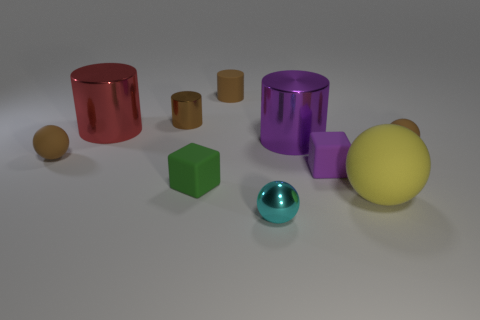Is the material of the big yellow sphere the same as the large purple cylinder?
Offer a terse response. No. What number of tiny brown things are the same shape as the large purple shiny thing?
Your response must be concise. 2. There is a big object that is the same material as the small purple object; what is its shape?
Offer a very short reply. Sphere. There is a metallic ball in front of the small brown ball right of the big yellow ball; what is its color?
Provide a succinct answer. Cyan. Is the color of the tiny rubber cylinder the same as the tiny metal ball?
Your response must be concise. No. What is the material of the small sphere on the right side of the purple object in front of the big purple metal cylinder?
Your answer should be compact. Rubber. What material is the big red object that is the same shape as the purple shiny thing?
Keep it short and to the point. Metal. There is a small rubber ball to the right of the small ball left of the brown matte cylinder; are there any brown matte cylinders that are in front of it?
Provide a short and direct response. No. How many other objects are the same color as the metal ball?
Provide a succinct answer. 0. What number of things are both right of the small purple cube and behind the large purple cylinder?
Keep it short and to the point. 0. 